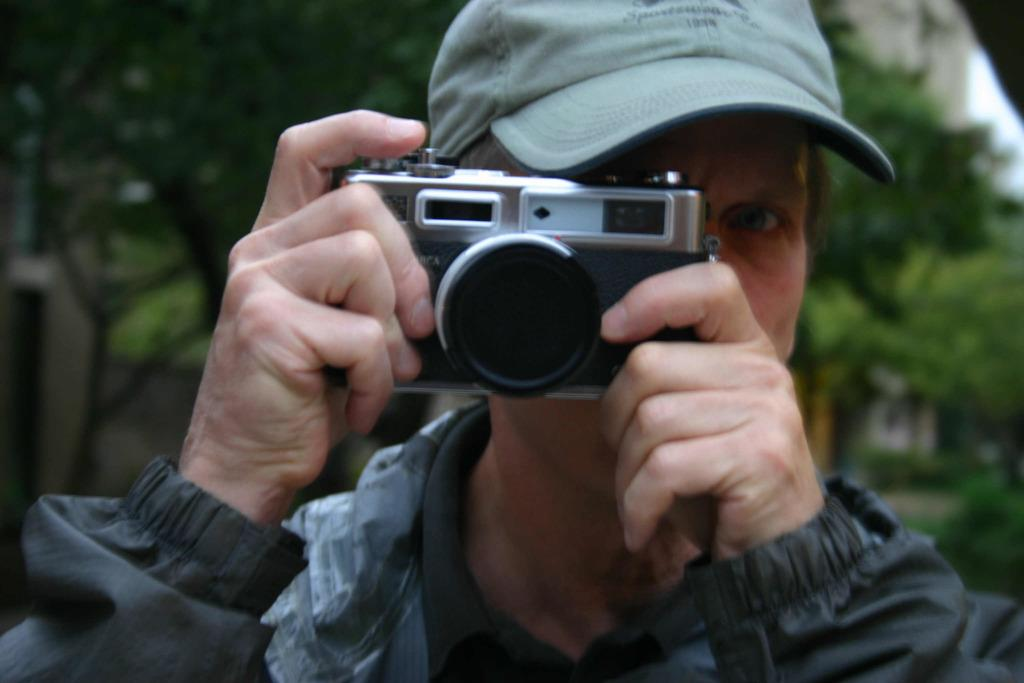Who is the main subject in the image? There is a man in the picture. What is the man wearing on his head? The man is wearing a cap. What is the man holding in the image? The man is holding a camera. What is the man doing with the camera? The man is taking a picture. What can be seen in the background of the image? There are trees in the background of the image. What is the tendency of the square in the image? There is no square present in the image, so it is not possible to determine any tendencies. 